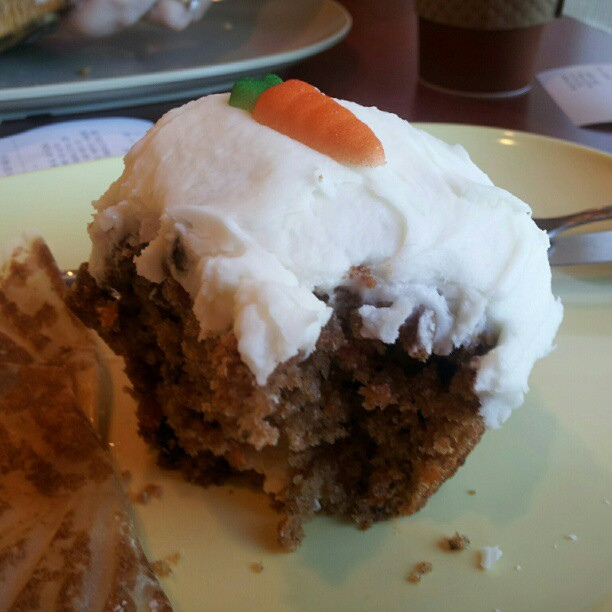<image>What is covering the outside of the bun? I am not sure what is covering the outside of the bun. It could be frosting, icing or nothing. What kind of cheese is on the food? There is no cheese on the food. However, it can be cream cheese. What is to the right of the bun? It is unknown what is to the right of the bun, it could be a cake, a plate, or even a utensil. However, there is also a response indicating no bun in the image. What is covering the outside of the bun? I am not sure what is covering the outside of the bun. It can be frosting or icing. What kind of cheese is on the food? I'm not sure what kind of cheese is on the food. It can be cream, cream cheese or none. What is to the right of the bun? It is ambiguous what is to the right of the bun. It can be cake, muffin wrapper, plate, fork or carrot cake. 